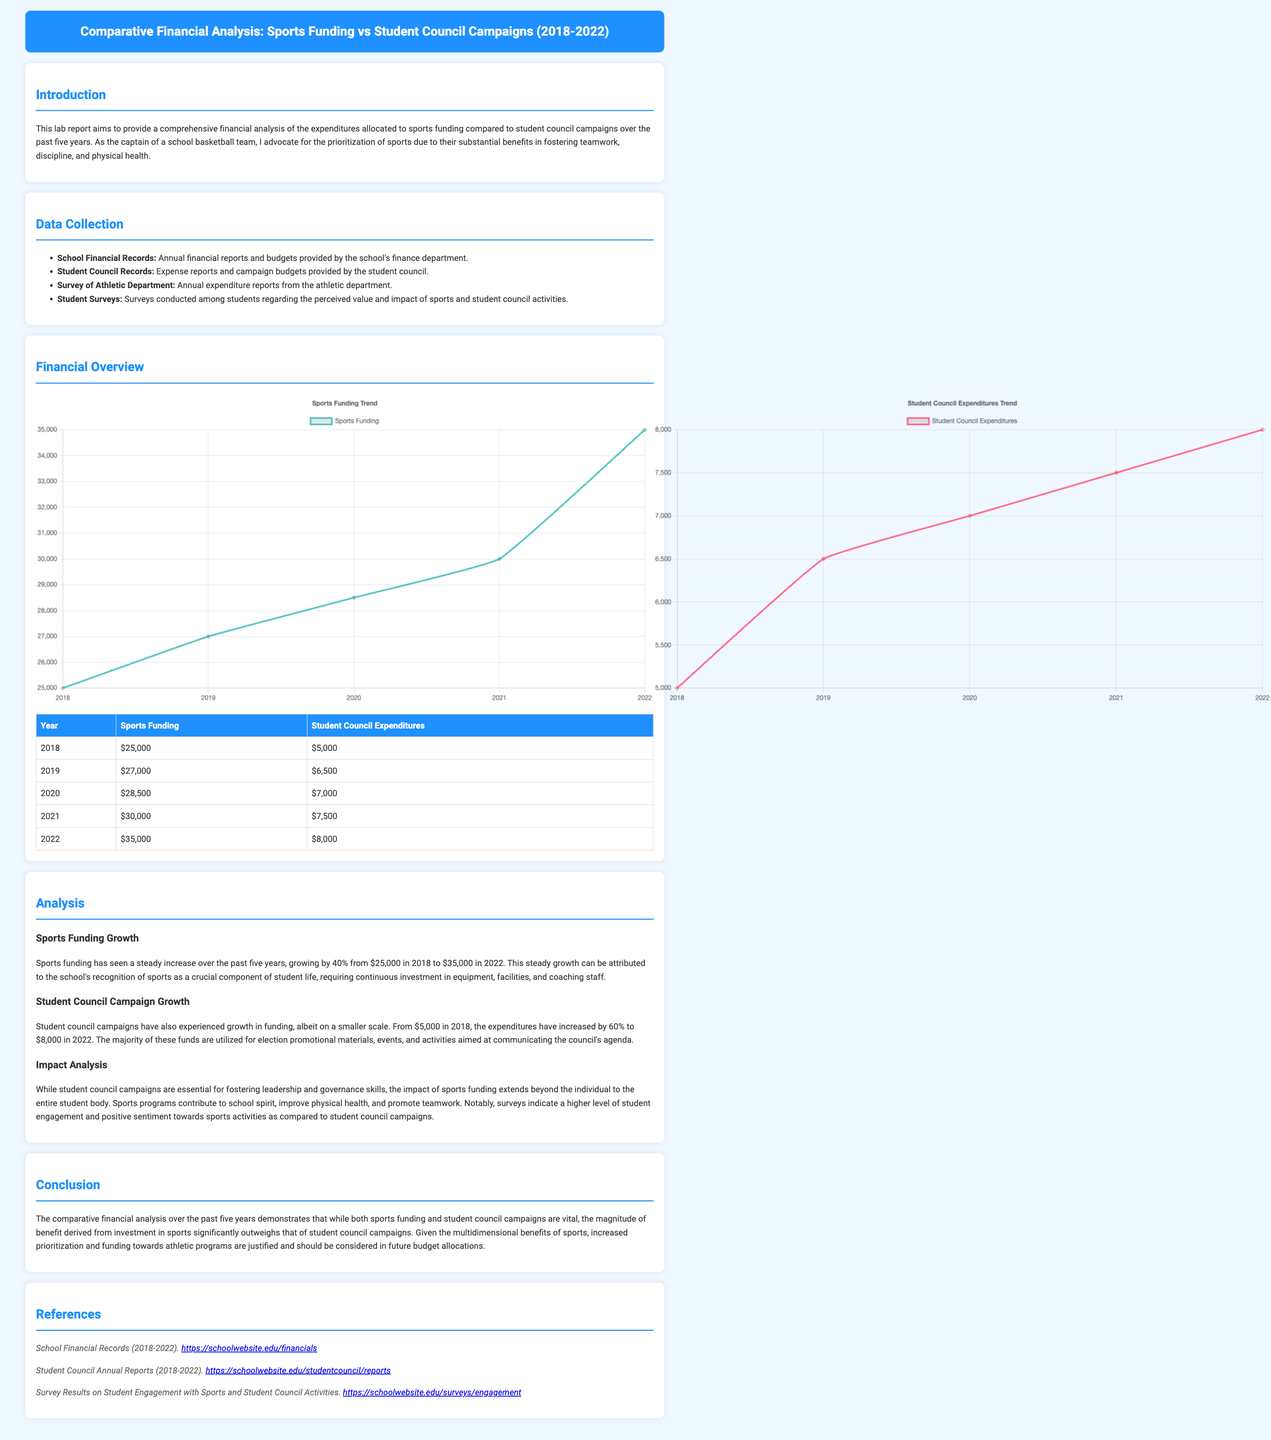what was the sports funding in 2018? The sports funding for 2018 can be found in the financial overview table, which reports a value of $25,000.
Answer: $25,000 what was the increase in student council expenditures from 2018 to 2022? The increase is calculated by subtracting the 2018 expenditures ($5,000) from the 2022 expenditures ($8,000), which gives a difference of $3,000.
Answer: $3,000 how much did sports funding grow in percentage from 2018 to 2022? The growth percentage is determined by noting the increase from $25,000 to $35,000, which constitutes a 40% increase over the period.
Answer: 40% what year saw the lowest student council expenditures? The document provides financial data that shows 2018 had the lowest student council expenditures at $5,000.
Answer: 2018 which funding had a higher total amount in 2022? By comparing the amounts from 2022, sports funding at $35,000 is higher than student council expenditures, which were $8,000.
Answer: Sports funding what is the primary benefit mentioned for sports funding? The document states that sports funding contributes to school spirit, improves physical health, and promotes teamwork.
Answer: School spirit how many years does the report cover? The report analyzes the financial data over a span of five years from 2018 to 2022.
Answer: Five years what is the main focus of the introduction section? The introduction outlines the purpose of the report, which is to analyze expenditures on sports versus student council activities.
Answer: Financial analysis what does the analysis suggest about the prioritization of sports? The analysis concludes that the benefits gained from sports funding justify increased prioritization in future budget allocations.
Answer: Increased prioritization 